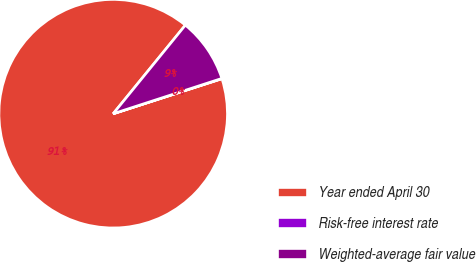<chart> <loc_0><loc_0><loc_500><loc_500><pie_chart><fcel>Year ended April 30<fcel>Risk-free interest rate<fcel>Weighted-average fair value<nl><fcel>90.85%<fcel>0.04%<fcel>9.12%<nl></chart> 